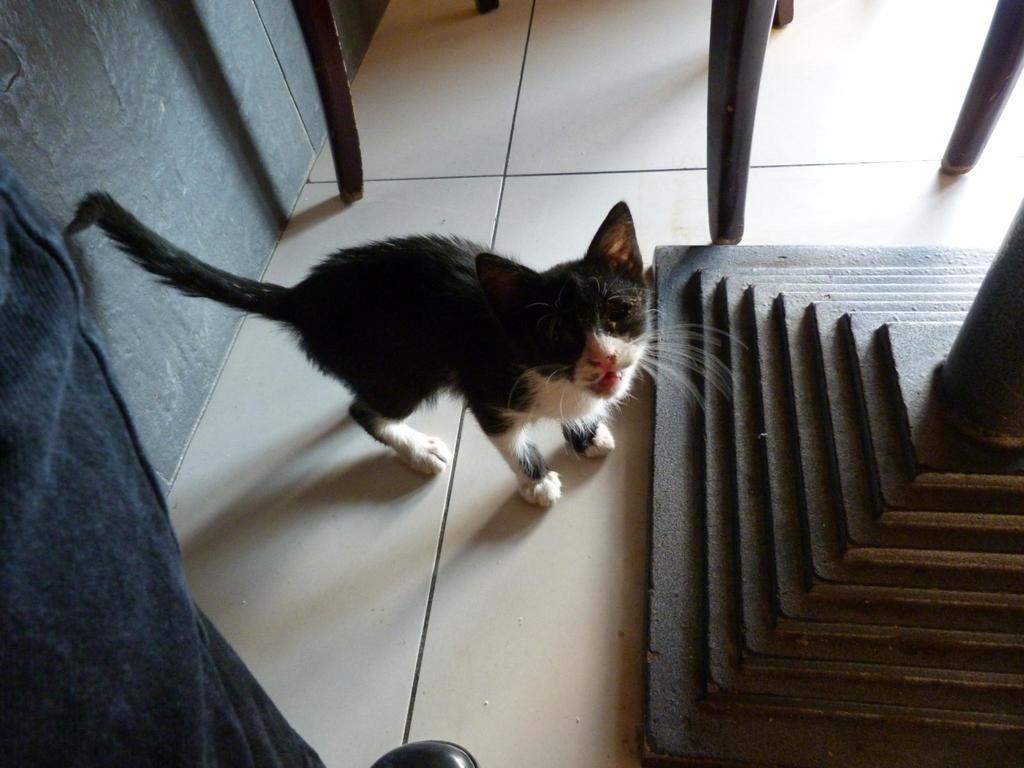What type of animal can be seen in the image? There is a cat in the image. What is the background of the image? There is a wall in the image. What else can be seen in the image besides the cat and the wall? There are some objects in the image. How does the cat burst into flames in the image? The cat does not burst into flames in the image; there is no indication of fire or any other destructive force. 